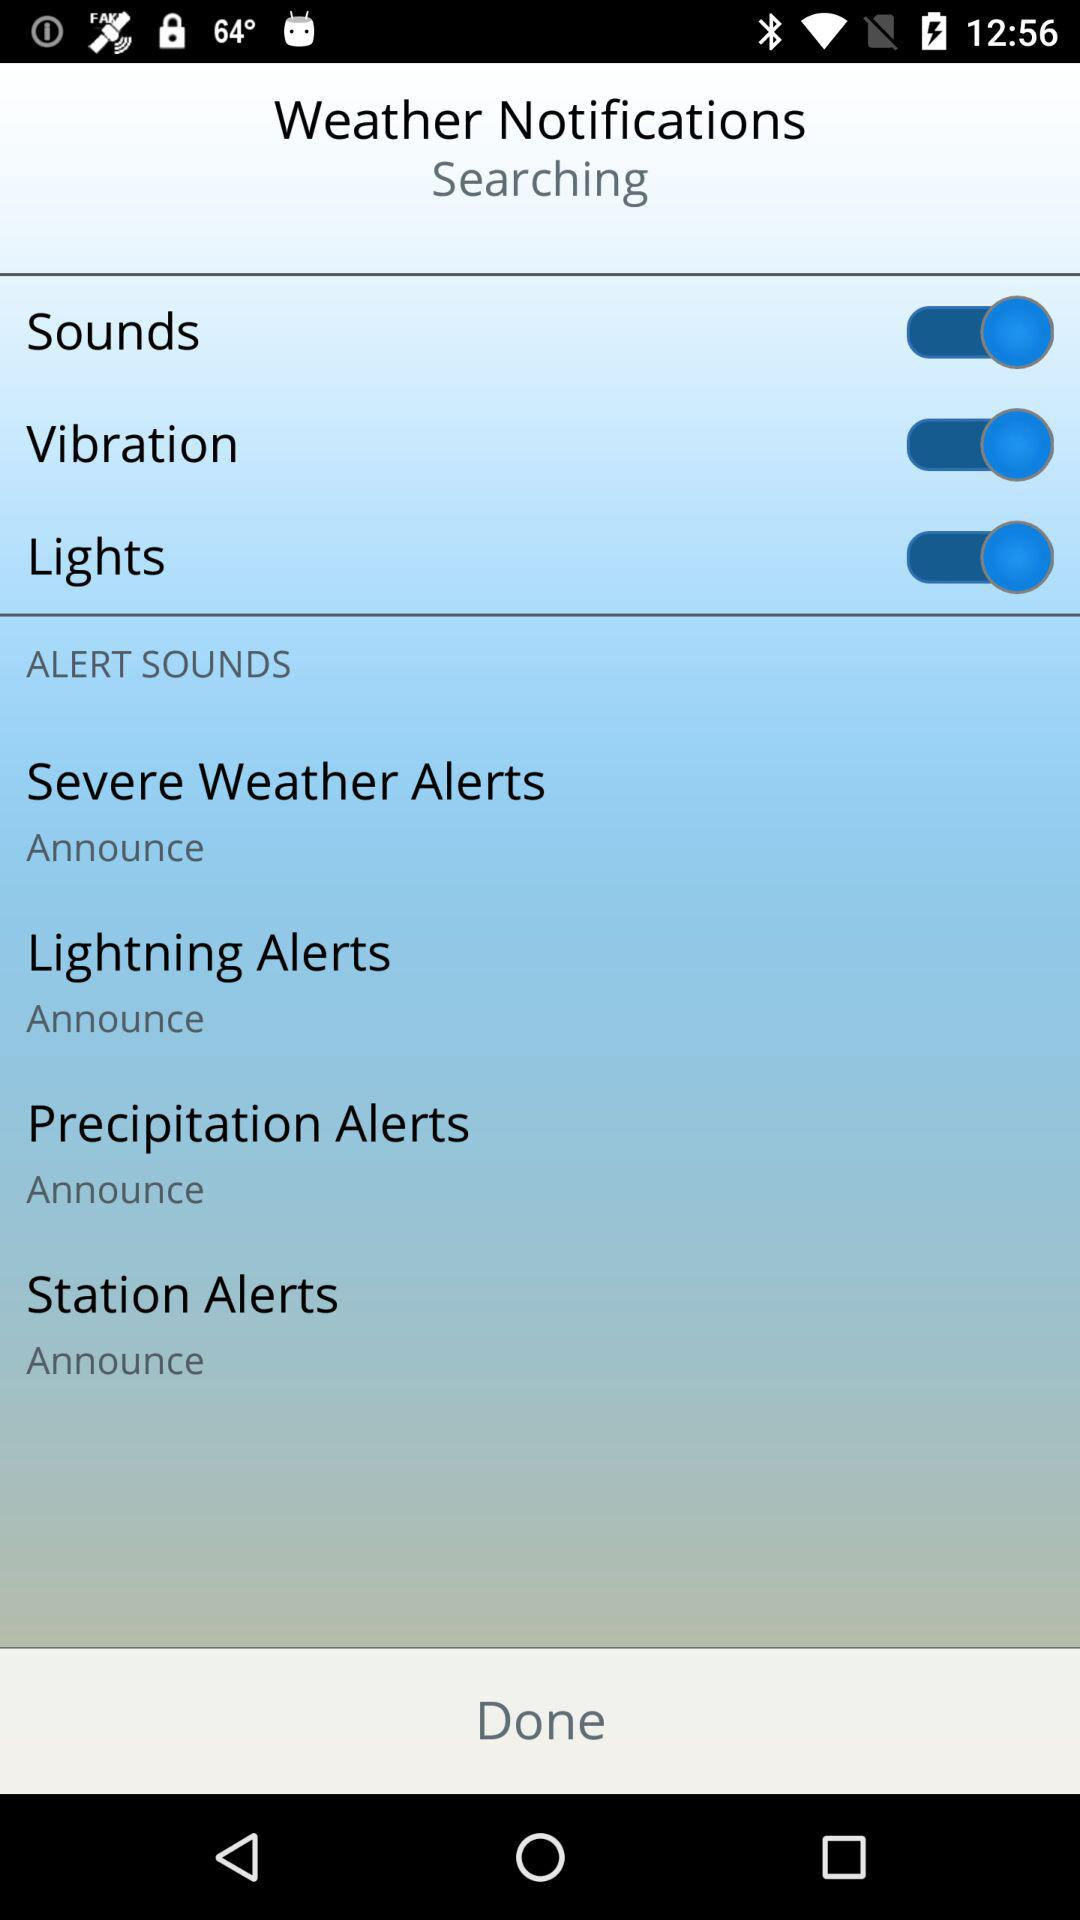How many alert sounds are there?
Answer the question using a single word or phrase. 4 